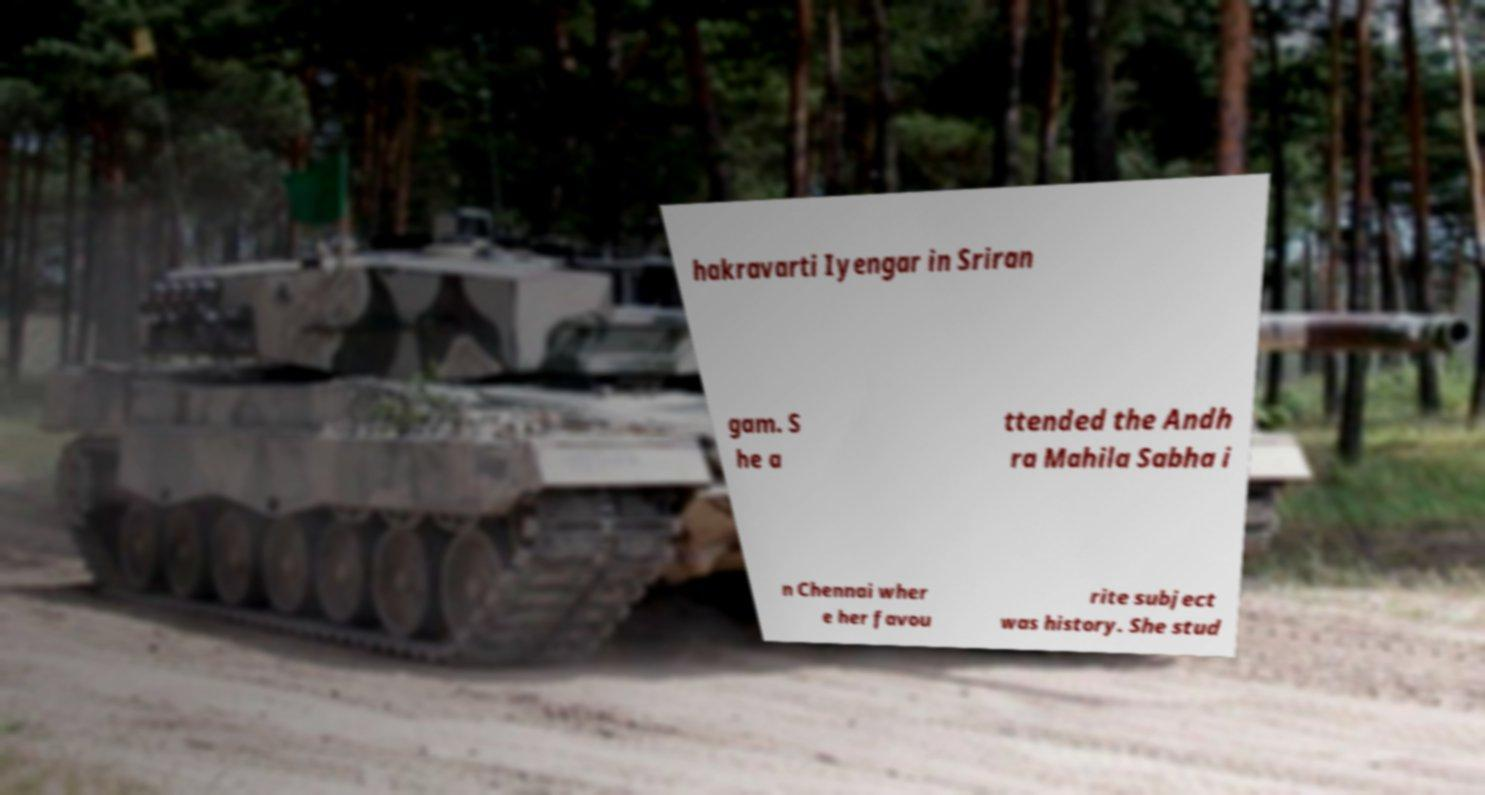What messages or text are displayed in this image? I need them in a readable, typed format. hakravarti Iyengar in Sriran gam. S he a ttended the Andh ra Mahila Sabha i n Chennai wher e her favou rite subject was history. She stud 